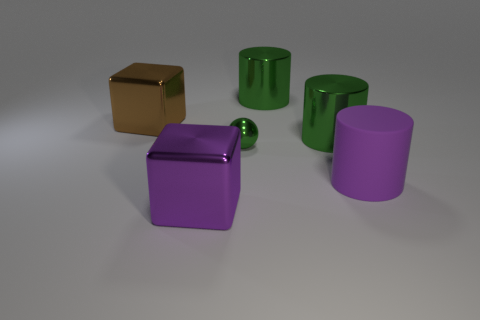Subtract all green cylinders. How many cylinders are left? 1 Subtract all red cubes. How many green cylinders are left? 2 Subtract all purple cylinders. How many cylinders are left? 2 Add 2 small green shiny balls. How many objects exist? 8 Subtract all spheres. How many objects are left? 5 Subtract 1 cylinders. How many cylinders are left? 2 Add 4 big green metallic cylinders. How many big green metallic cylinders exist? 6 Subtract 0 red cylinders. How many objects are left? 6 Subtract all brown cylinders. Subtract all gray blocks. How many cylinders are left? 3 Subtract all large yellow matte blocks. Subtract all metal blocks. How many objects are left? 4 